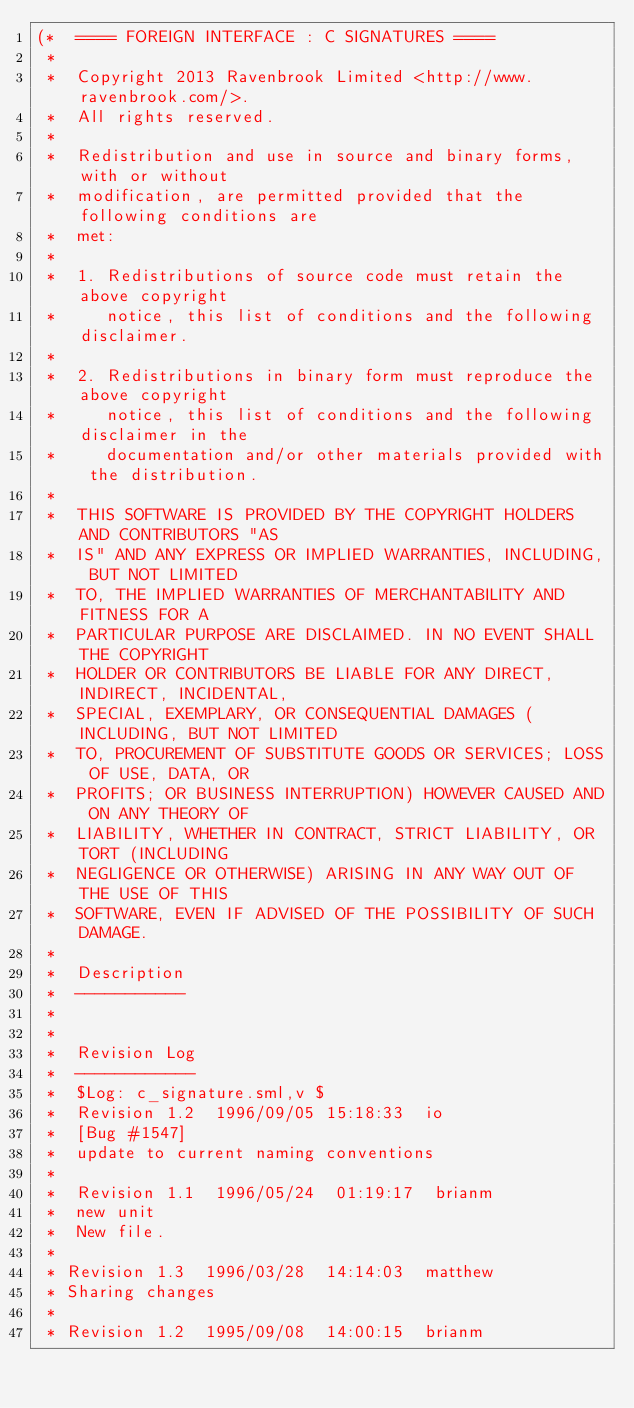Convert code to text. <code><loc_0><loc_0><loc_500><loc_500><_SML_>(*  ==== FOREIGN INTERFACE : C SIGNATURES ====
 *
 *  Copyright 2013 Ravenbrook Limited <http://www.ravenbrook.com/>.
 *  All rights reserved.
 *  
 *  Redistribution and use in source and binary forms, with or without
 *  modification, are permitted provided that the following conditions are
 *  met:
 *  
 *  1. Redistributions of source code must retain the above copyright
 *     notice, this list of conditions and the following disclaimer.
 *  
 *  2. Redistributions in binary form must reproduce the above copyright
 *     notice, this list of conditions and the following disclaimer in the
 *     documentation and/or other materials provided with the distribution.
 *  
 *  THIS SOFTWARE IS PROVIDED BY THE COPYRIGHT HOLDERS AND CONTRIBUTORS "AS
 *  IS" AND ANY EXPRESS OR IMPLIED WARRANTIES, INCLUDING, BUT NOT LIMITED
 *  TO, THE IMPLIED WARRANTIES OF MERCHANTABILITY AND FITNESS FOR A
 *  PARTICULAR PURPOSE ARE DISCLAIMED. IN NO EVENT SHALL THE COPYRIGHT
 *  HOLDER OR CONTRIBUTORS BE LIABLE FOR ANY DIRECT, INDIRECT, INCIDENTAL,
 *  SPECIAL, EXEMPLARY, OR CONSEQUENTIAL DAMAGES (INCLUDING, BUT NOT LIMITED
 *  TO, PROCUREMENT OF SUBSTITUTE GOODS OR SERVICES; LOSS OF USE, DATA, OR
 *  PROFITS; OR BUSINESS INTERRUPTION) HOWEVER CAUSED AND ON ANY THEORY OF
 *  LIABILITY, WHETHER IN CONTRACT, STRICT LIABILITY, OR TORT (INCLUDING
 *  NEGLIGENCE OR OTHERWISE) ARISING IN ANY WAY OUT OF THE USE OF THIS
 *  SOFTWARE, EVEN IF ADVISED OF THE POSSIBILITY OF SUCH DAMAGE.
 *
 *  Description
 *  -----------
 *
 *
 *  Revision Log
 *  ------------
 *  $Log: c_signature.sml,v $
 *  Revision 1.2  1996/09/05 15:18:33  io
 *  [Bug #1547]
 *  update to current naming conventions
 *
 *  Revision 1.1  1996/05/24  01:19:17  brianm
 *  new unit
 *  New file.
 *
 * Revision 1.3  1996/03/28  14:14:03  matthew
 * Sharing changes
 *
 * Revision 1.2  1995/09/08  14:00:15  brianm</code> 